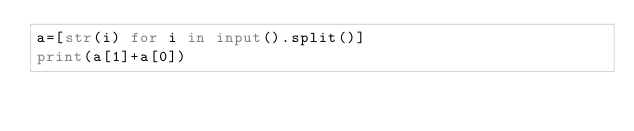Convert code to text. <code><loc_0><loc_0><loc_500><loc_500><_Python_>a=[str(i) for i in input().split()]
print(a[1]+a[0])
</code> 